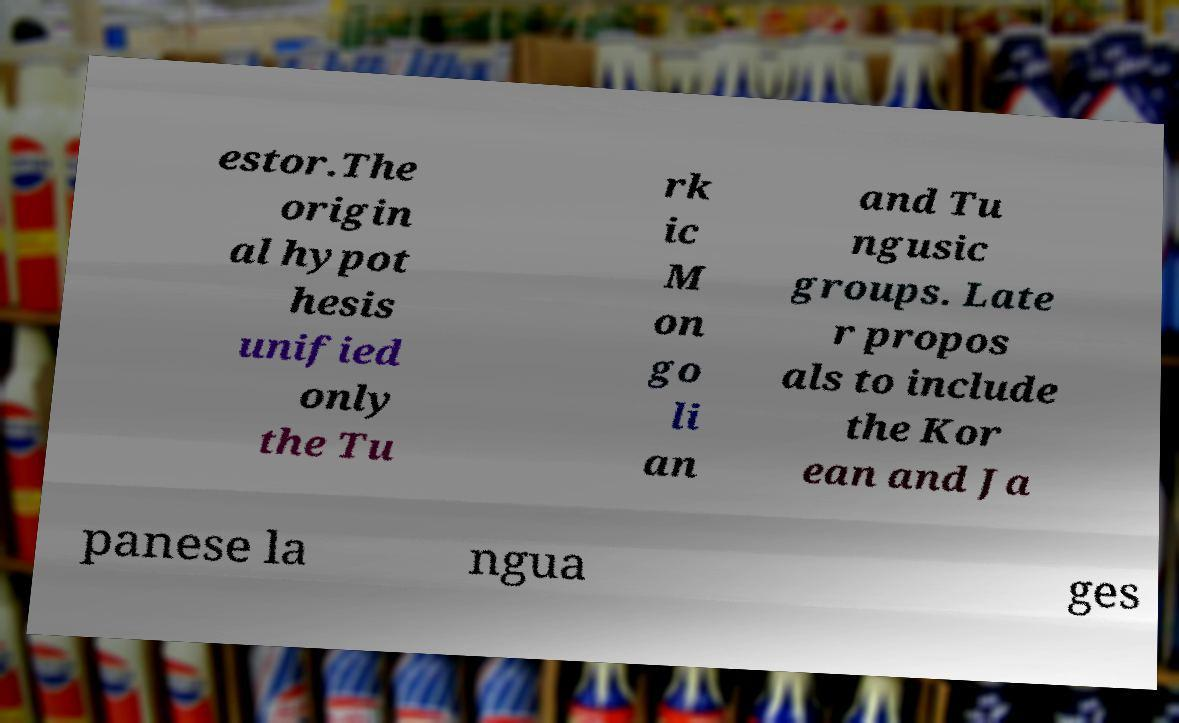There's text embedded in this image that I need extracted. Can you transcribe it verbatim? estor.The origin al hypot hesis unified only the Tu rk ic M on go li an and Tu ngusic groups. Late r propos als to include the Kor ean and Ja panese la ngua ges 